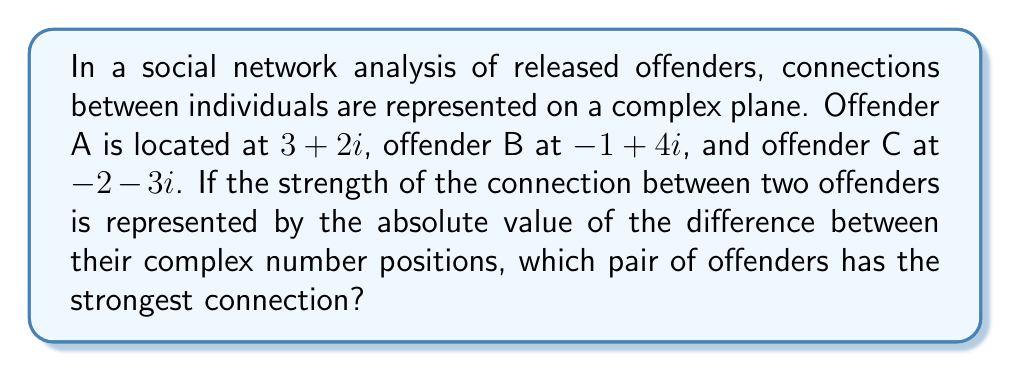What is the answer to this math problem? To solve this problem, we need to calculate the absolute value of the difference between each pair of offenders' complex number positions and compare them:

1. Connection between A and B:
   $|(3+2i) - (-1+4i)| = |(4-2i)| = \sqrt{4^2 + (-2)^2} = \sqrt{16 + 4} = \sqrt{20} = 2\sqrt{5}$

2. Connection between A and C:
   $|(3+2i) - (-2-3i)| = |(5+5i)| = \sqrt{5^2 + 5^2} = \sqrt{50} = 5\sqrt{2}$

3. Connection between B and C:
   $|(-1+4i) - (-2-3i)| = |(1+7i)| = \sqrt{1^2 + 7^2} = \sqrt{50} = 5\sqrt{2}$

Comparing the results:
$2\sqrt{5} \approx 4.47$
$5\sqrt{2} \approx 7.07$

The largest value represents the strongest connection, which is $5\sqrt{2}$.
Answer: Offenders A and C, or B and C (both have a connection strength of $5\sqrt{2}$) 